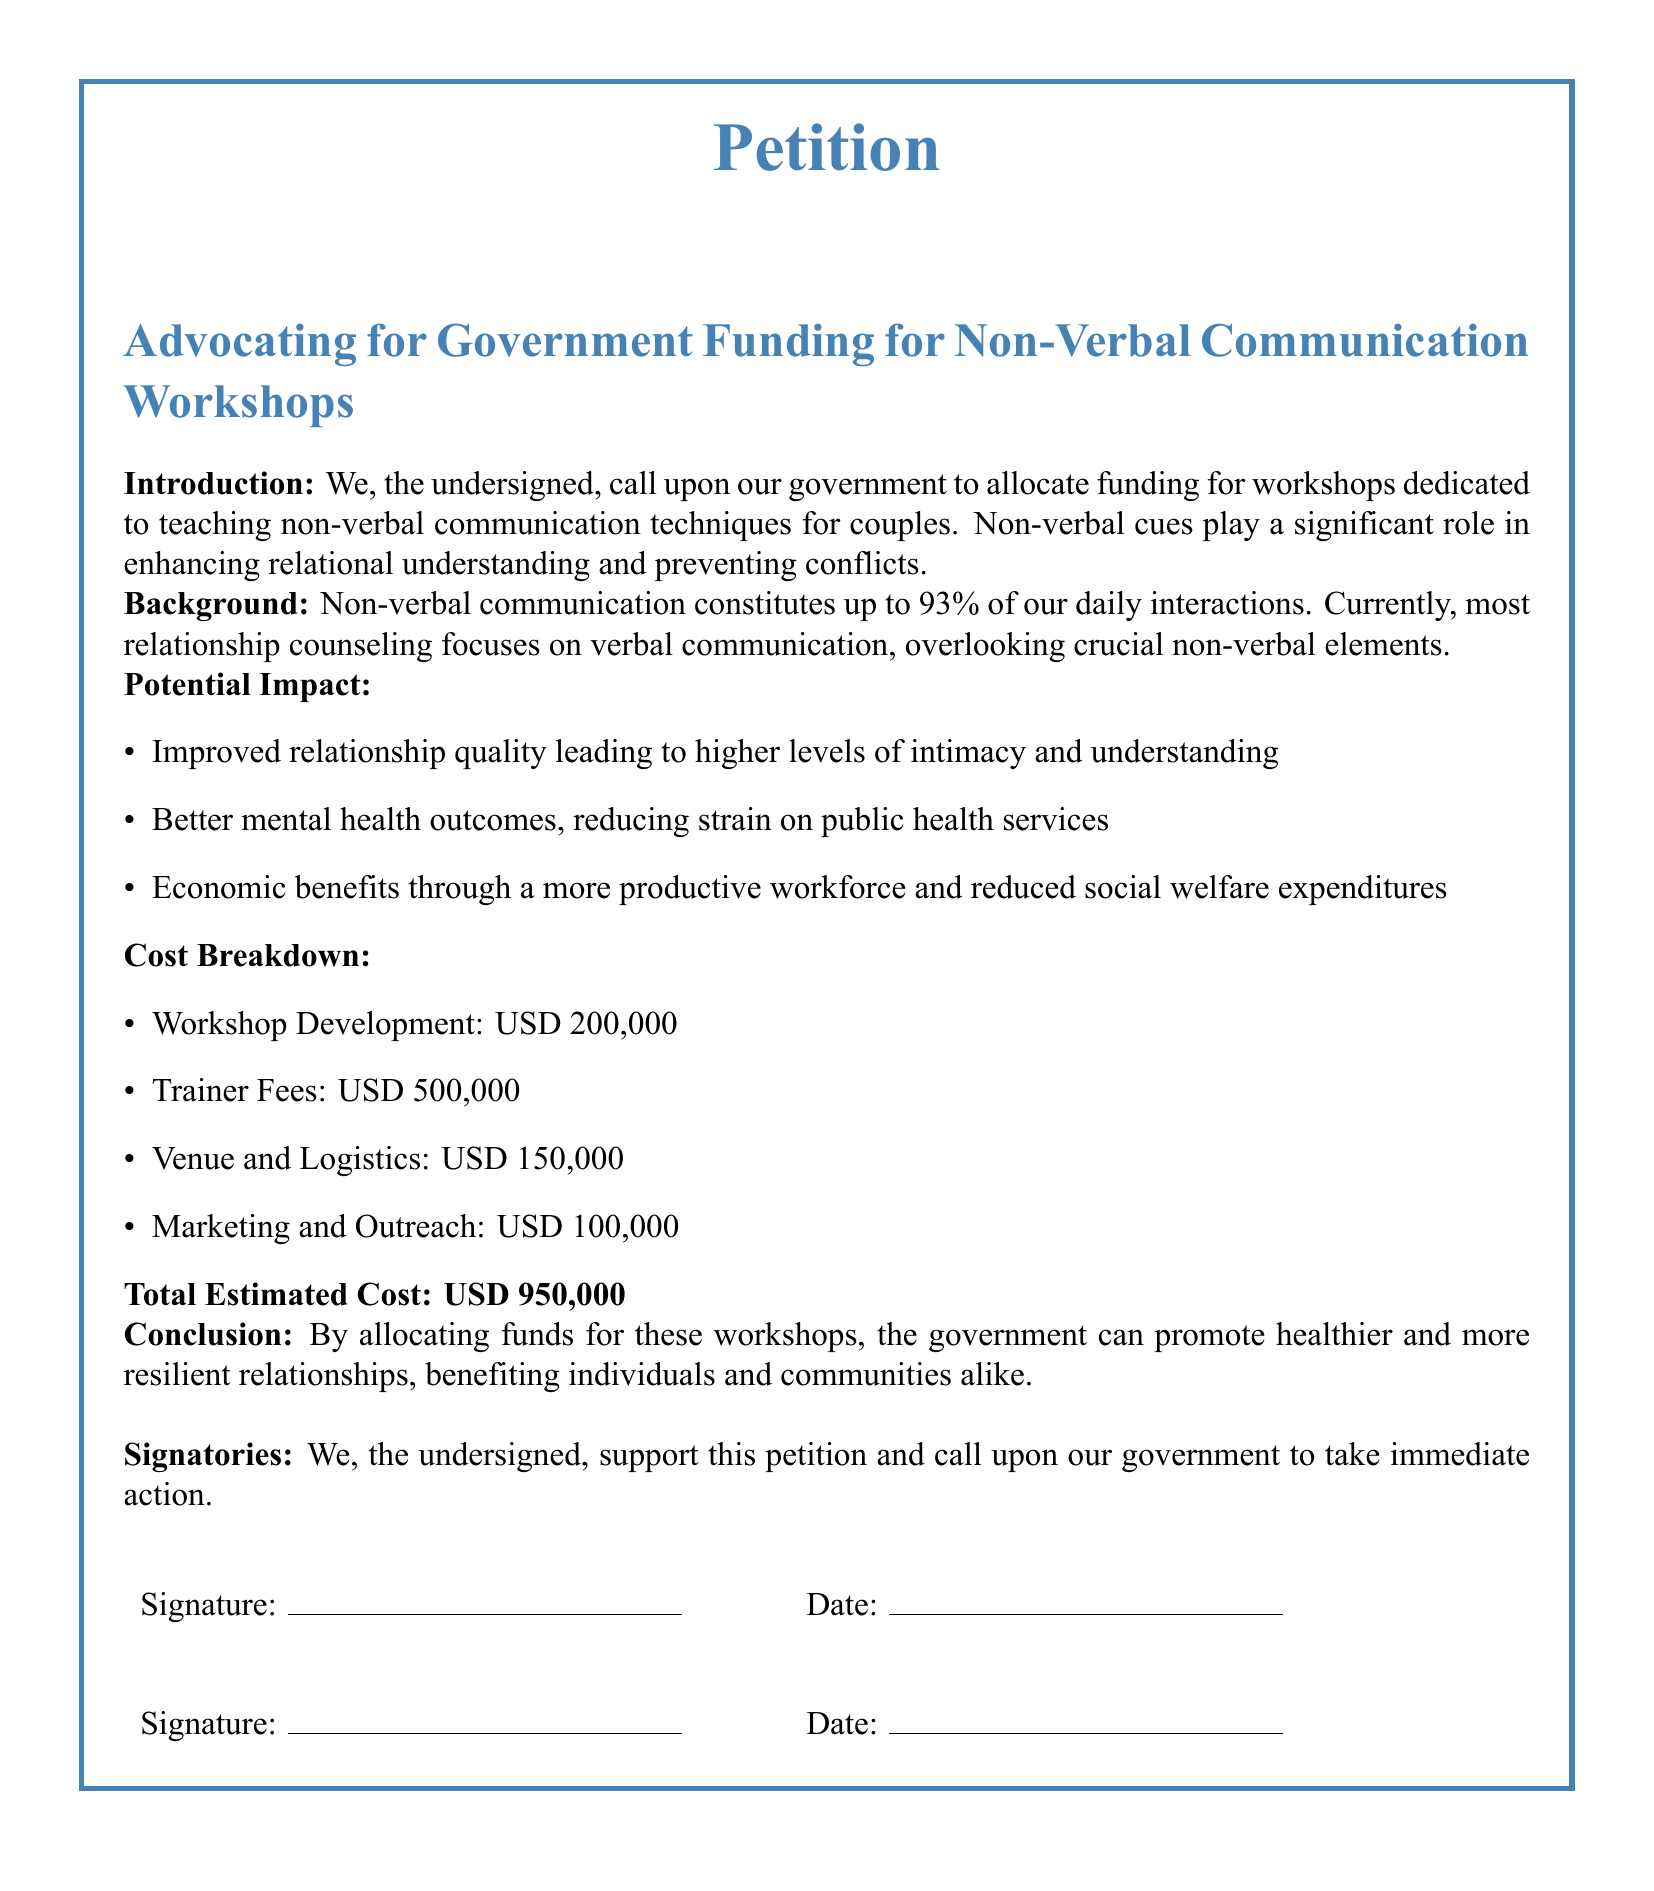What is the total estimated cost of the workshops? The total estimated cost is calculated by summing all expenses listed in the cost breakdown section.
Answer: USD 950,000 What is the primary focus of the workshops proposed in the petition? The workshops are focused on teaching non-verbal communication techniques for couples to enhance relational understanding.
Answer: Non-verbal communication techniques What percentage of daily interactions does non-verbal communication constitute, according to the document? The document states that non-verbal communication constitutes 93% of daily interactions.
Answer: 93% What are the two primary benefits mentioned for better mental health outcomes? The benefits mentioned include reduced strain on public health services and improved relationship quality.
Answer: Reduced strain on public health services How much is allocated for trainer fees in the cost breakdown? The amount allocated for trainer fees is explicitly stated in the cost breakdown of the document.
Answer: USD 500,000 What recommendation does the conclusion of the petition make to the government? The conclusion recommends the government allocate funds for workshops to promote healthier relationships.
Answer: Allocate funds for workshops What type of document is this? The structure and purpose reveal that it is a petition directed to the government regarding funding.
Answer: Petition What is one of the economic benefits listed in the potential impact section? The document mentions a more productive workforce as one of the economic benefits.
Answer: More productive workforce What is the purpose of the signatures at the end of the petition? The signatures serve to demonstrate support for the petition's call to action directed at the government.
Answer: Demonstrate support 